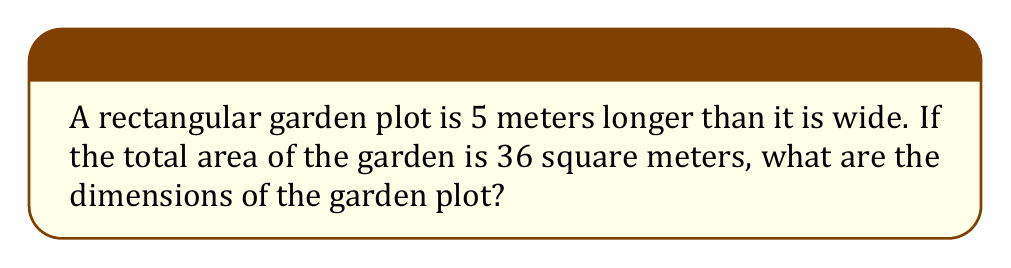Can you solve this math problem? Let's approach this step-by-step:

1) Let's define our variables:
   Let $w$ = width of the garden
   Let $l$ = length of the garden

2) We're told that the length is 5 meters longer than the width, so we can express this as:
   $l = w + 5$

3) We know that the area of a rectangle is length times width:
   $Area = l \times w$

4) We're told the area is 36 square meters, so we can set up our equation:
   $36 = l \times w$

5) Substituting what we know about the length:
   $36 = (w + 5) \times w$

6) Expand this:
   $36 = w^2 + 5w$

7) Rearrange to standard form:
   $w^2 + 5w - 36 = 0$

8) This is a quadratic equation. We can solve it using the quadratic formula:
   $w = \frac{-b \pm \sqrt{b^2 - 4ac}}{2a}$

   Where $a = 1$, $b = 5$, and $c = -36$

9) Plugging in these values:
   $w = \frac{-5 \pm \sqrt{5^2 - 4(1)(-36)}}{2(1)}$
   $= \frac{-5 \pm \sqrt{25 + 144}}{2}$
   $= \frac{-5 \pm \sqrt{169}}{2}$
   $= \frac{-5 \pm 13}{2}$

10) This gives us two solutions:
    $w = \frac{-5 + 13}{2} = 4$ or $w = \frac{-5 - 13}{2} = -9$

11) Since width can't be negative, we use $w = 4$

12) If $w = 4$, then $l = w + 5 = 4 + 5 = 9$

Therefore, the dimensions of the garden are 4 meters wide and 9 meters long.
Answer: The dimensions of the garden plot are 4 meters wide and 9 meters long. 